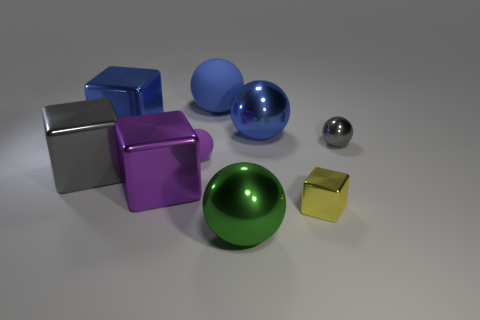There is a block that is the same color as the tiny rubber object; what is its material?
Provide a short and direct response. Metal. What number of objects are small metal objects that are behind the yellow block or gray things that are left of the purple metal block?
Offer a very short reply. 2. Are there more big green balls to the right of the big purple object than small matte things?
Make the answer very short. No. What number of other objects are the same shape as the purple shiny thing?
Provide a short and direct response. 3. There is a tiny object that is behind the tiny metal cube and to the right of the big blue rubber thing; what material is it?
Ensure brevity in your answer.  Metal. How many things are either cyan objects or blue spheres?
Offer a terse response. 2. Are there more green metal cubes than large blue objects?
Keep it short and to the point. No. How big is the gray object that is right of the gray thing on the left side of the small block?
Your answer should be compact. Small. The tiny rubber thing that is the same shape as the big blue rubber thing is what color?
Make the answer very short. Purple. How big is the gray metal sphere?
Your answer should be very brief. Small. 